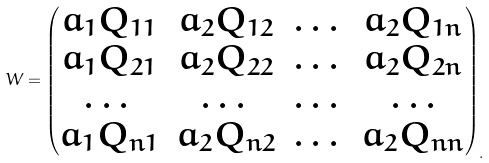<formula> <loc_0><loc_0><loc_500><loc_500>W = \begin{pmatrix} a _ { 1 } Q _ { 1 1 } & a _ { 2 } Q _ { 1 2 } & \dots & a _ { 2 } Q _ { 1 n } \\ a _ { 1 } Q _ { 2 1 } & a _ { 2 } Q _ { 2 2 } & \dots & a _ { 2 } Q _ { 2 n } \\ \dots & \dots & \dots & \dots \\ a _ { 1 } Q _ { n 1 } & a _ { 2 } Q _ { n 2 } & \dots & a _ { 2 } Q _ { n n } \end{pmatrix} _ { . }</formula> 